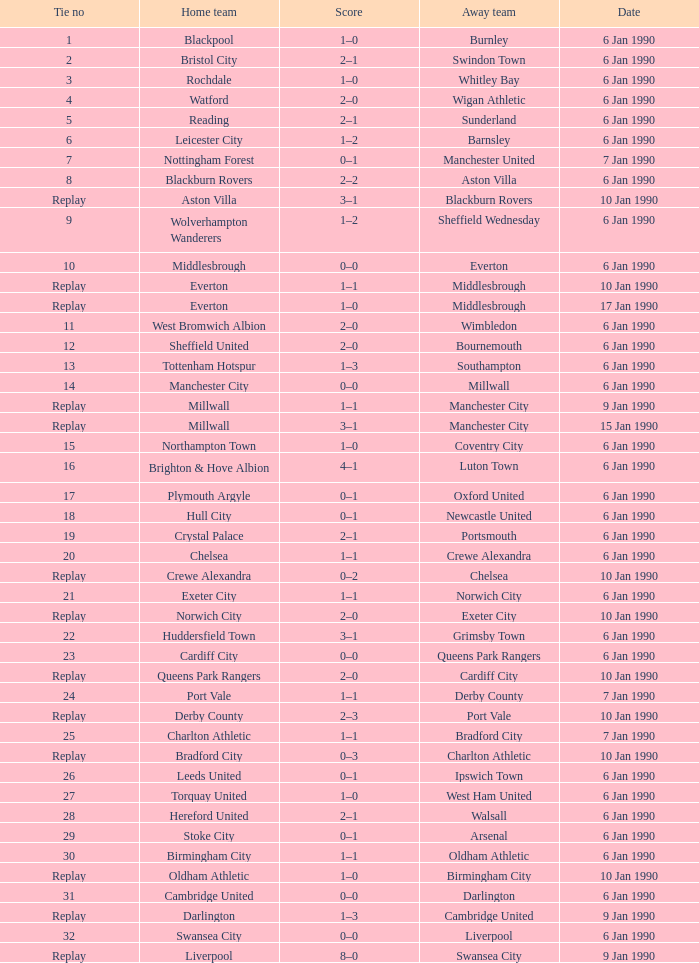On january 10, 1990, what was the outcome of the game with exeter city playing as the away team? 2–0. 